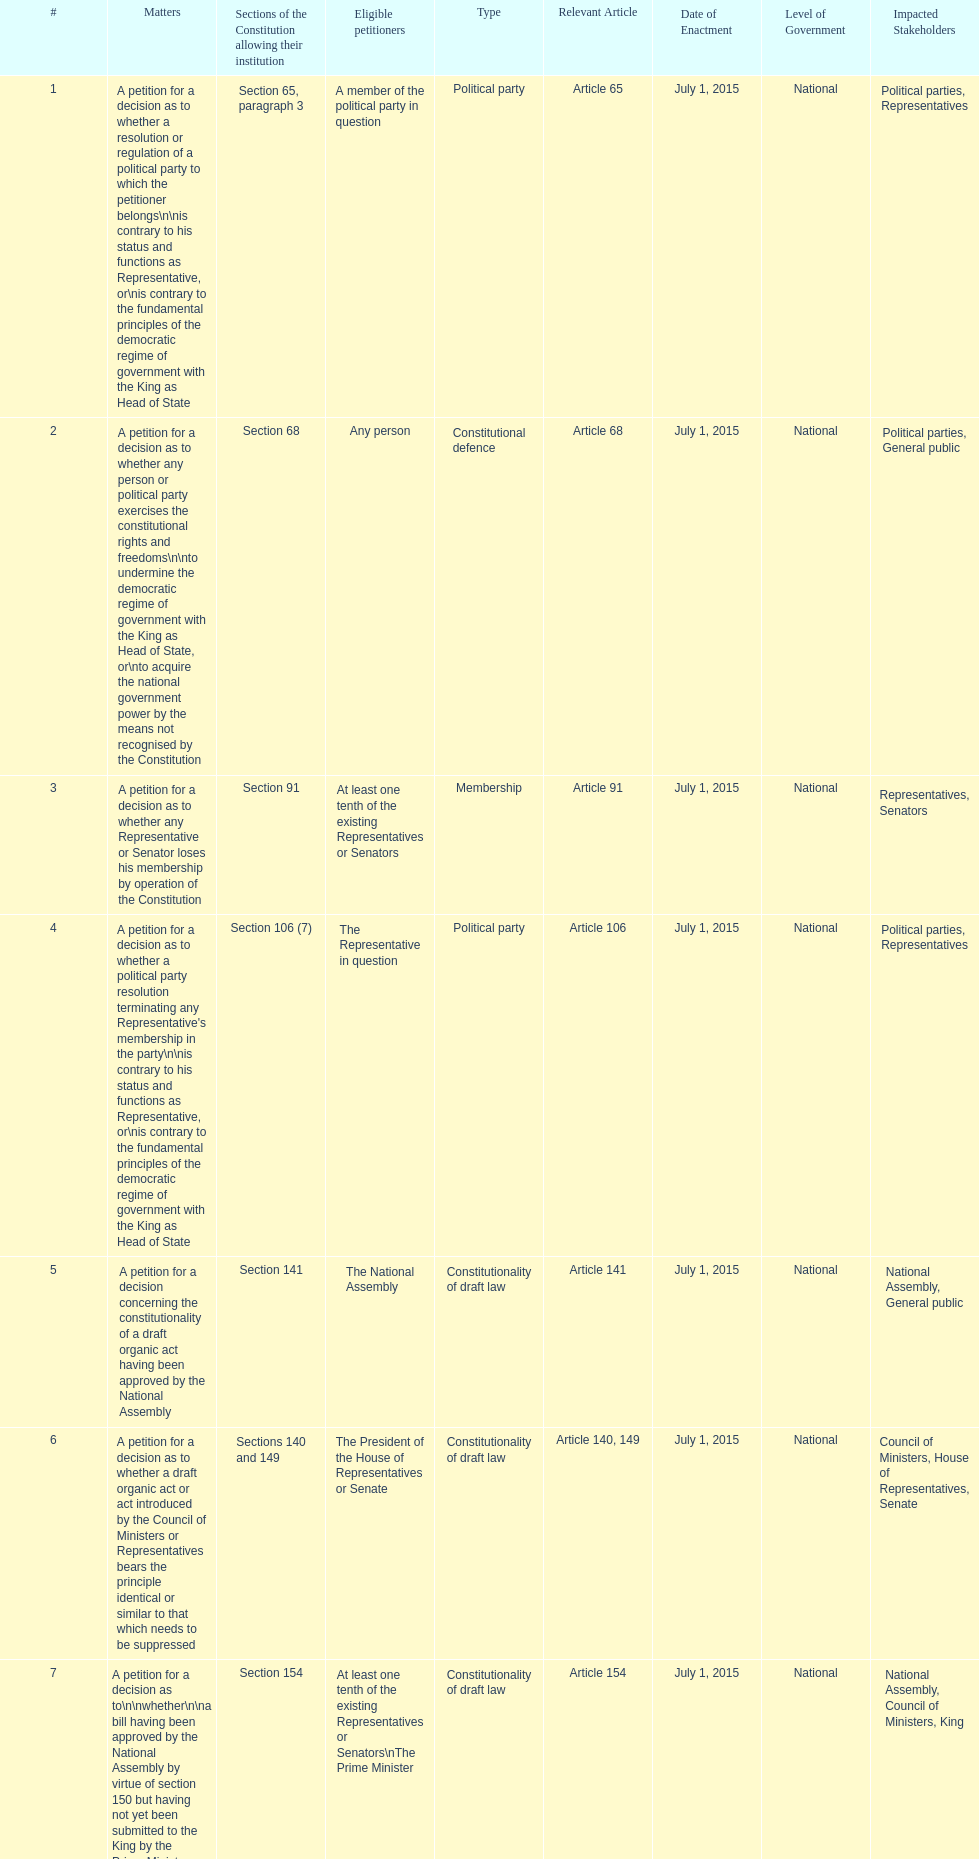Any person can petition matters 2 and 17. true or false? True. 